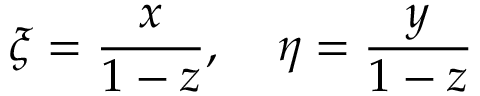<formula> <loc_0><loc_0><loc_500><loc_500>\xi = \frac { x } { 1 - z } , \, \eta = \frac { y } { 1 - z }</formula> 